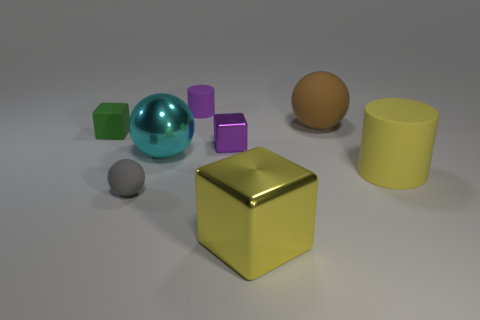Add 1 big purple shiny spheres. How many objects exist? 9 Subtract all cyan shiny balls. How many balls are left? 2 Subtract all gray cylinders. How many purple cubes are left? 1 Subtract all cyan balls. How many balls are left? 2 Subtract 1 green blocks. How many objects are left? 7 Subtract all blocks. How many objects are left? 5 Subtract 2 balls. How many balls are left? 1 Subtract all yellow spheres. Subtract all purple blocks. How many spheres are left? 3 Subtract all big brown metal cylinders. Subtract all large matte balls. How many objects are left? 7 Add 3 tiny purple shiny cubes. How many tiny purple shiny cubes are left? 4 